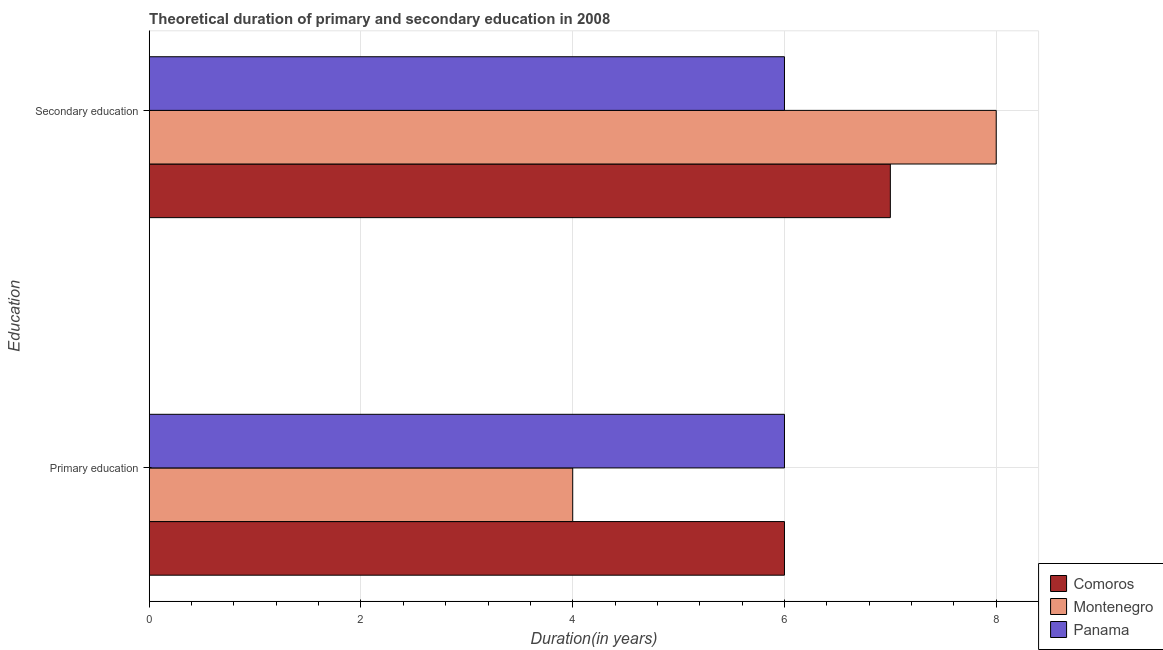How many different coloured bars are there?
Offer a very short reply. 3. Are the number of bars per tick equal to the number of legend labels?
Ensure brevity in your answer.  Yes. How many bars are there on the 1st tick from the top?
Make the answer very short. 3. How many bars are there on the 2nd tick from the bottom?
Provide a succinct answer. 3. What is the label of the 1st group of bars from the top?
Give a very brief answer. Secondary education. What is the duration of primary education in Montenegro?
Keep it short and to the point. 4. Across all countries, what is the maximum duration of primary education?
Your response must be concise. 6. Across all countries, what is the minimum duration of primary education?
Keep it short and to the point. 4. In which country was the duration of secondary education maximum?
Make the answer very short. Montenegro. In which country was the duration of secondary education minimum?
Make the answer very short. Panama. What is the total duration of secondary education in the graph?
Keep it short and to the point. 21. What is the difference between the duration of primary education in Montenegro and that in Comoros?
Provide a short and direct response. -2. What is the difference between the duration of secondary education in Montenegro and the duration of primary education in Panama?
Ensure brevity in your answer.  2. What is the average duration of secondary education per country?
Offer a very short reply. 7. What is the difference between the duration of primary education and duration of secondary education in Montenegro?
Make the answer very short. -4. In how many countries, is the duration of secondary education greater than 1.6 years?
Your response must be concise. 3. In how many countries, is the duration of secondary education greater than the average duration of secondary education taken over all countries?
Offer a terse response. 1. What does the 2nd bar from the top in Secondary education represents?
Your response must be concise. Montenegro. What does the 1st bar from the bottom in Primary education represents?
Provide a succinct answer. Comoros. How many bars are there?
Offer a terse response. 6. How many countries are there in the graph?
Offer a terse response. 3. What is the difference between two consecutive major ticks on the X-axis?
Provide a succinct answer. 2. What is the title of the graph?
Provide a succinct answer. Theoretical duration of primary and secondary education in 2008. What is the label or title of the X-axis?
Provide a succinct answer. Duration(in years). What is the label or title of the Y-axis?
Keep it short and to the point. Education. What is the Duration(in years) of Comoros in Primary education?
Offer a terse response. 6. What is the Duration(in years) of Montenegro in Primary education?
Your response must be concise. 4. What is the Duration(in years) of Montenegro in Secondary education?
Your answer should be compact. 8. Across all Education, what is the minimum Duration(in years) of Comoros?
Keep it short and to the point. 6. Across all Education, what is the minimum Duration(in years) of Montenegro?
Offer a very short reply. 4. Across all Education, what is the minimum Duration(in years) in Panama?
Your answer should be compact. 6. What is the difference between the Duration(in years) of Comoros in Primary education and that in Secondary education?
Give a very brief answer. -1. What is the difference between the Duration(in years) in Comoros in Primary education and the Duration(in years) in Montenegro in Secondary education?
Provide a short and direct response. -2. What is the difference between the Duration(in years) in Comoros in Primary education and the Duration(in years) in Panama in Secondary education?
Your answer should be very brief. 0. What is the difference between the Duration(in years) in Montenegro in Primary education and the Duration(in years) in Panama in Secondary education?
Provide a succinct answer. -2. What is the difference between the Duration(in years) in Comoros and Duration(in years) in Montenegro in Secondary education?
Your response must be concise. -1. What is the difference between the Duration(in years) of Comoros and Duration(in years) of Panama in Secondary education?
Offer a very short reply. 1. What is the ratio of the Duration(in years) of Comoros in Primary education to that in Secondary education?
Your answer should be very brief. 0.86. What is the ratio of the Duration(in years) of Montenegro in Primary education to that in Secondary education?
Your response must be concise. 0.5. What is the difference between the highest and the second highest Duration(in years) of Montenegro?
Offer a terse response. 4. What is the difference between the highest and the lowest Duration(in years) in Comoros?
Give a very brief answer. 1. What is the difference between the highest and the lowest Duration(in years) of Panama?
Keep it short and to the point. 0. 